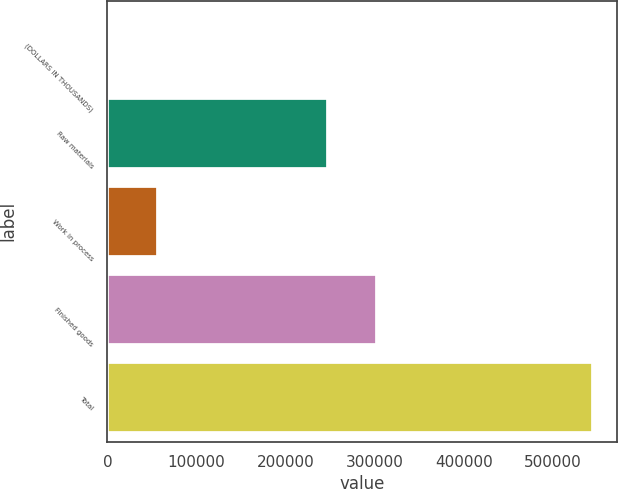<chart> <loc_0><loc_0><loc_500><loc_500><bar_chart><fcel>(DOLLARS IN THOUSANDS)<fcel>Raw materials<fcel>Work in process<fcel>Finished goods<fcel>Total<nl><fcel>2011<fcel>248050<fcel>56253.8<fcel>302293<fcel>544439<nl></chart> 